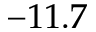Convert formula to latex. <formula><loc_0><loc_0><loc_500><loc_500>- 1 1 . 7</formula> 